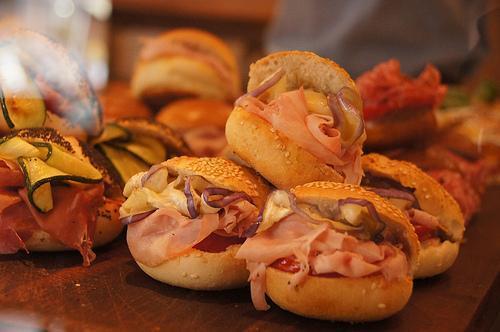How many kinds of buns are there?
Give a very brief answer. 2. 